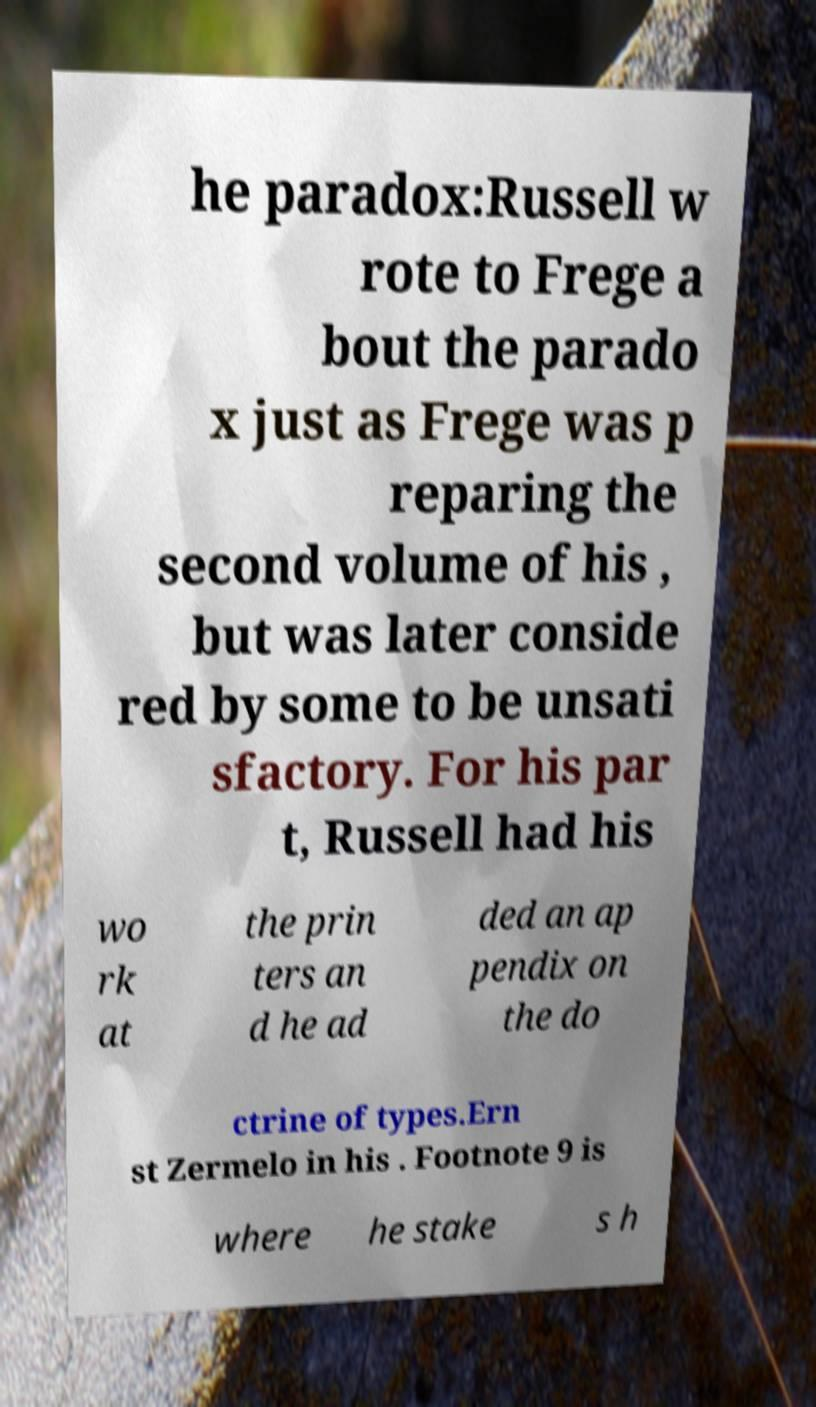Please read and relay the text visible in this image. What does it say? he paradox:Russell w rote to Frege a bout the parado x just as Frege was p reparing the second volume of his , but was later conside red by some to be unsati sfactory. For his par t, Russell had his wo rk at the prin ters an d he ad ded an ap pendix on the do ctrine of types.Ern st Zermelo in his . Footnote 9 is where he stake s h 